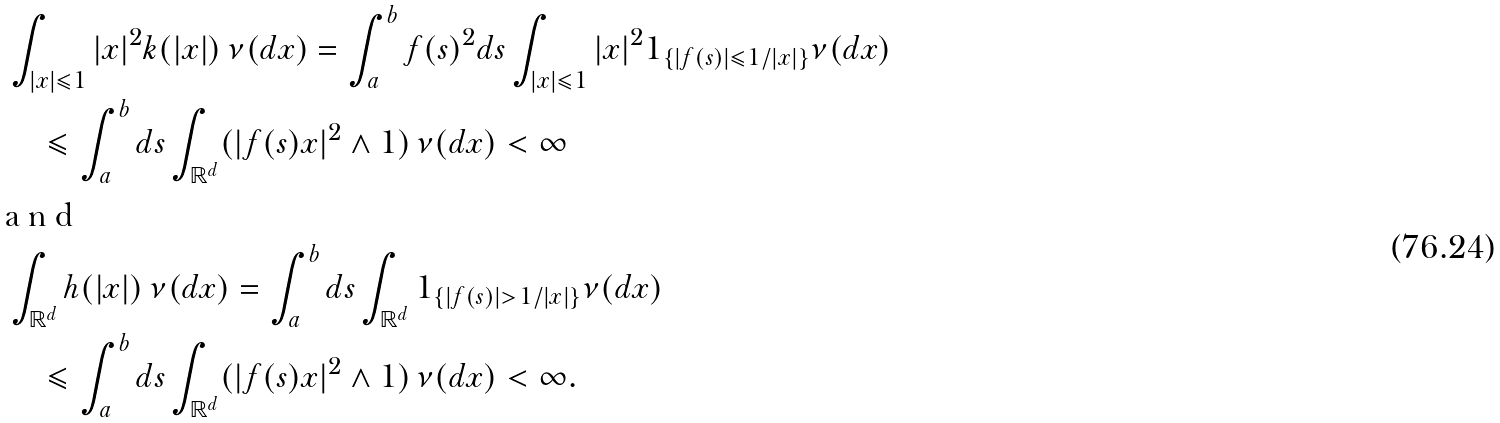<formula> <loc_0><loc_0><loc_500><loc_500>& \int _ { | x | \leqslant 1 } | x | ^ { 2 } k ( | x | ) \, \nu ( d x ) = \int _ { a } ^ { b } f ( s ) ^ { 2 } d s \int _ { | x | \leqslant 1 } | x | ^ { 2 } 1 _ { \{ | f ( s ) | \leqslant 1 / | x | \} } \nu ( d x ) \\ & \quad \leqslant \int _ { a } ^ { b } d s \int _ { \mathbb { R } ^ { d } } ( | f ( s ) x | ^ { 2 } \land 1 ) \, \nu ( d x ) < \infty \\ \intertext { a n d } & \int _ { \mathbb { R } ^ { d } } h ( | x | ) \, \nu ( d x ) = \int _ { a } ^ { b } d s \int _ { \mathbb { R } ^ { d } } 1 _ { \{ | f ( s ) | > 1 / | x | \} } \nu ( d x ) \\ & \quad \leqslant \int _ { a } ^ { b } d s \int _ { \mathbb { R } ^ { d } } ( | f ( s ) x | ^ { 2 } \land 1 ) \, \nu ( d x ) < \infty .</formula> 